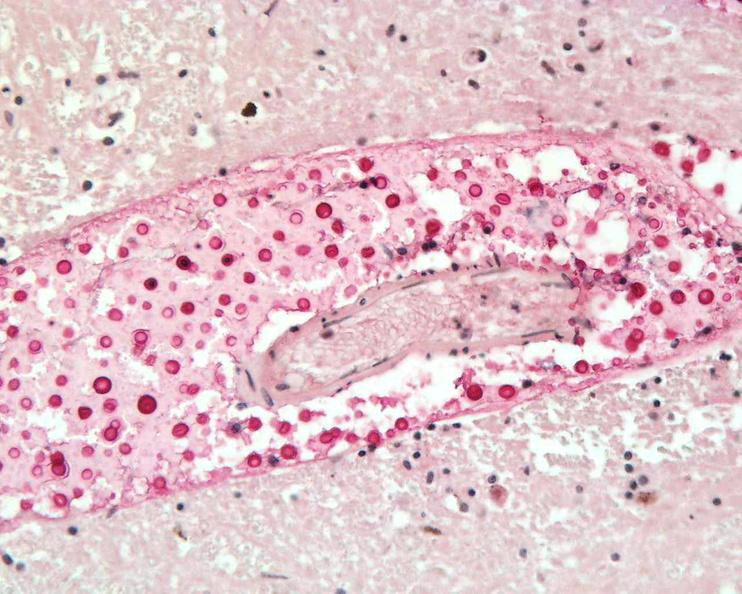s cut edge of mesentery present?
Answer the question using a single word or phrase. No 